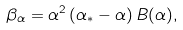Convert formula to latex. <formula><loc_0><loc_0><loc_500><loc_500>\beta _ { \alpha } = \alpha ^ { 2 } \left ( \alpha _ { * } - \alpha \right ) B ( \alpha ) ,</formula> 